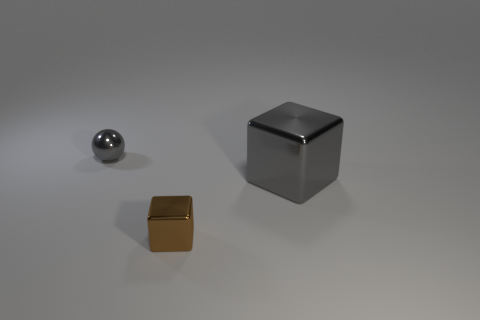Add 1 tiny objects. How many objects exist? 4 Subtract all cubes. How many objects are left? 1 Subtract all large cubes. Subtract all red cubes. How many objects are left? 2 Add 2 gray shiny things. How many gray shiny things are left? 4 Add 3 small matte cylinders. How many small matte cylinders exist? 3 Subtract 0 green cylinders. How many objects are left? 3 